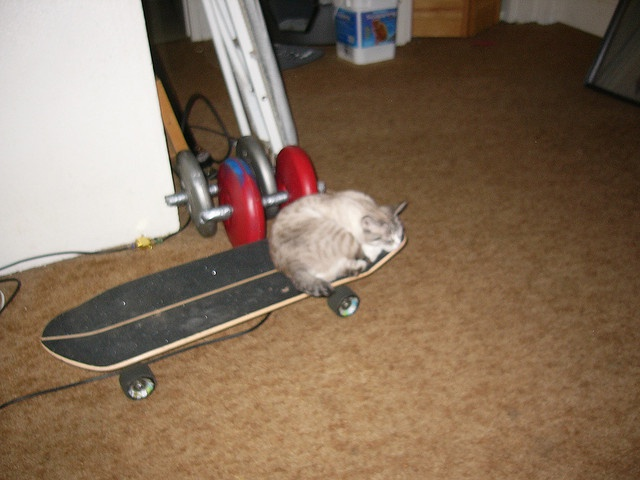Describe the objects in this image and their specific colors. I can see skateboard in lightgray, gray, and black tones and cat in lightgray, darkgray, and tan tones in this image. 